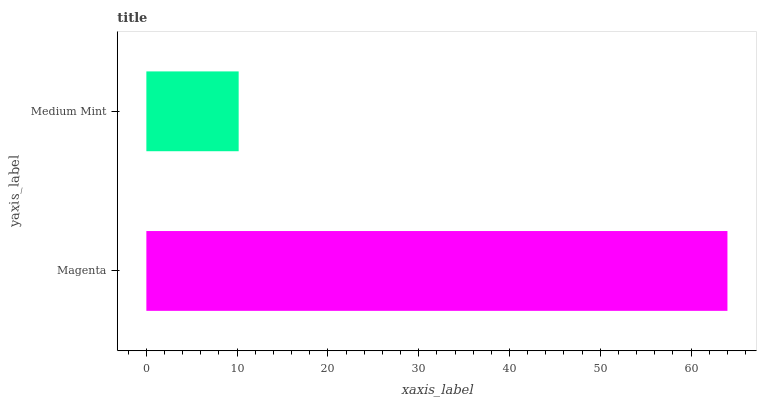Is Medium Mint the minimum?
Answer yes or no. Yes. Is Magenta the maximum?
Answer yes or no. Yes. Is Medium Mint the maximum?
Answer yes or no. No. Is Magenta greater than Medium Mint?
Answer yes or no. Yes. Is Medium Mint less than Magenta?
Answer yes or no. Yes. Is Medium Mint greater than Magenta?
Answer yes or no. No. Is Magenta less than Medium Mint?
Answer yes or no. No. Is Magenta the high median?
Answer yes or no. Yes. Is Medium Mint the low median?
Answer yes or no. Yes. Is Medium Mint the high median?
Answer yes or no. No. Is Magenta the low median?
Answer yes or no. No. 